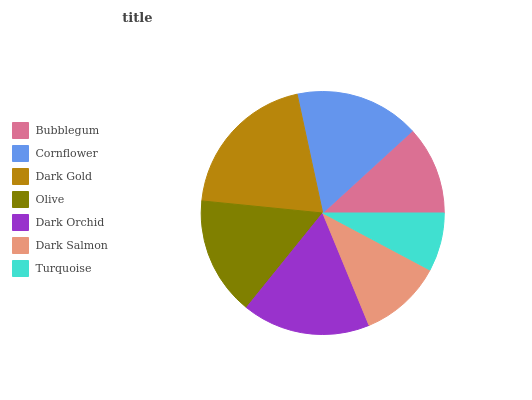Is Turquoise the minimum?
Answer yes or no. Yes. Is Dark Gold the maximum?
Answer yes or no. Yes. Is Cornflower the minimum?
Answer yes or no. No. Is Cornflower the maximum?
Answer yes or no. No. Is Cornflower greater than Bubblegum?
Answer yes or no. Yes. Is Bubblegum less than Cornflower?
Answer yes or no. Yes. Is Bubblegum greater than Cornflower?
Answer yes or no. No. Is Cornflower less than Bubblegum?
Answer yes or no. No. Is Olive the high median?
Answer yes or no. Yes. Is Olive the low median?
Answer yes or no. Yes. Is Turquoise the high median?
Answer yes or no. No. Is Dark Gold the low median?
Answer yes or no. No. 